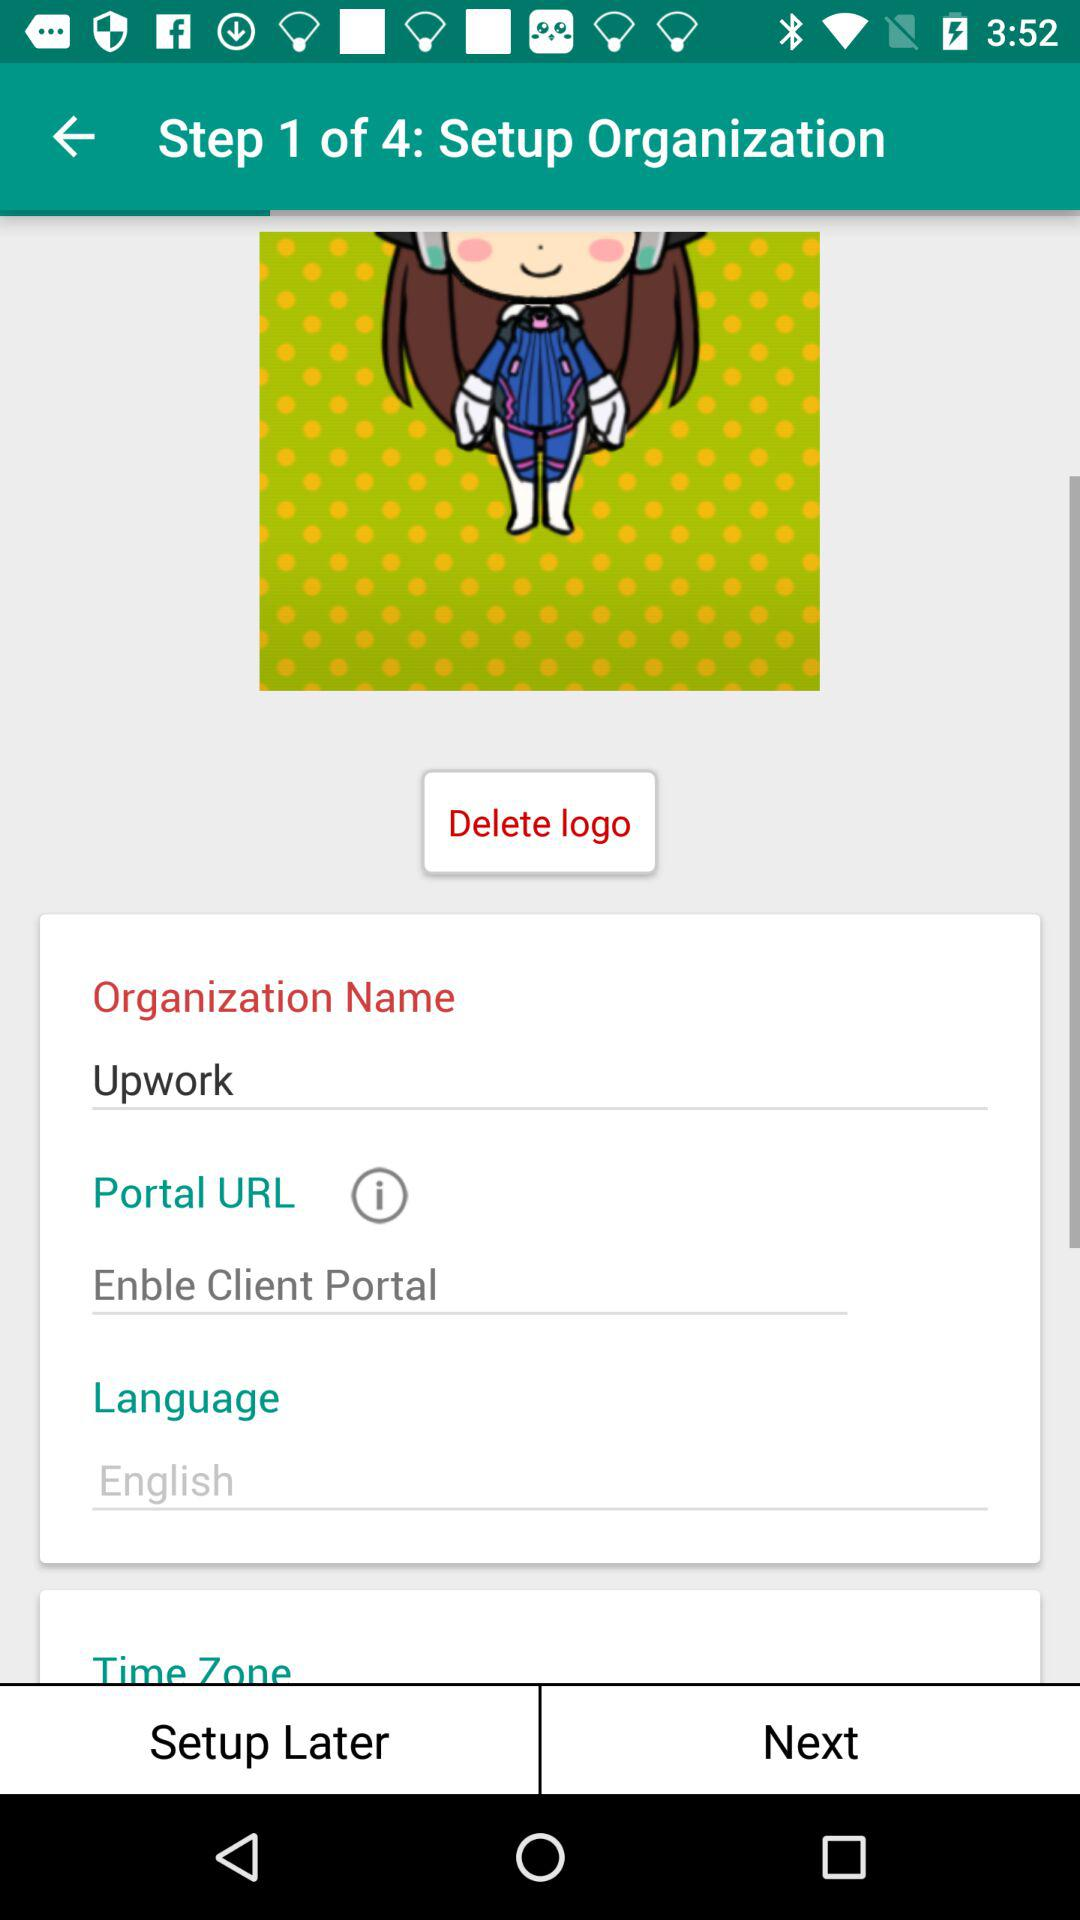How many steps are there in the setup process?
Answer the question using a single word or phrase. 4 